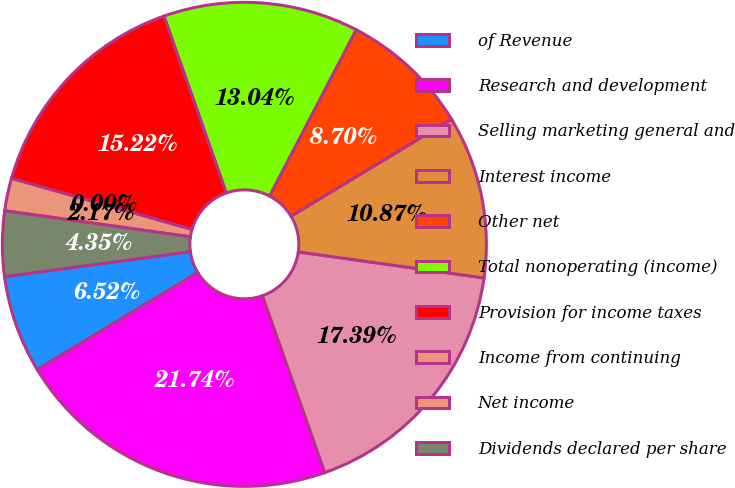<chart> <loc_0><loc_0><loc_500><loc_500><pie_chart><fcel>of Revenue<fcel>Research and development<fcel>Selling marketing general and<fcel>Interest income<fcel>Other net<fcel>Total nonoperating (income)<fcel>Provision for income taxes<fcel>Income from continuing<fcel>Net income<fcel>Dividends declared per share<nl><fcel>6.52%<fcel>21.74%<fcel>17.39%<fcel>10.87%<fcel>8.7%<fcel>13.04%<fcel>15.22%<fcel>0.0%<fcel>2.17%<fcel>4.35%<nl></chart> 